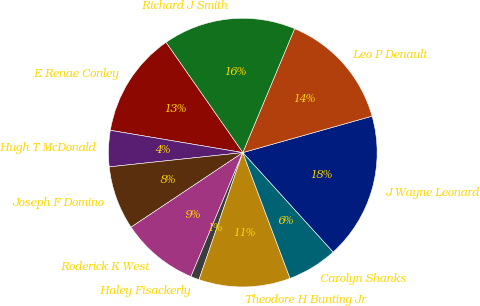<chart> <loc_0><loc_0><loc_500><loc_500><pie_chart><fcel>J Wayne Leonard<fcel>Leo P Denault<fcel>Richard J Smith<fcel>E Renae Conley<fcel>Hugh T McDonald<fcel>Joseph F Domino<fcel>Roderick K West<fcel>Haley Fisackerly<fcel>Theodore H Bunting Jr<fcel>Carolyn Shanks<nl><fcel>17.65%<fcel>14.32%<fcel>15.99%<fcel>12.66%<fcel>4.35%<fcel>7.67%<fcel>9.33%<fcel>1.02%<fcel>11.0%<fcel>6.01%<nl></chart> 